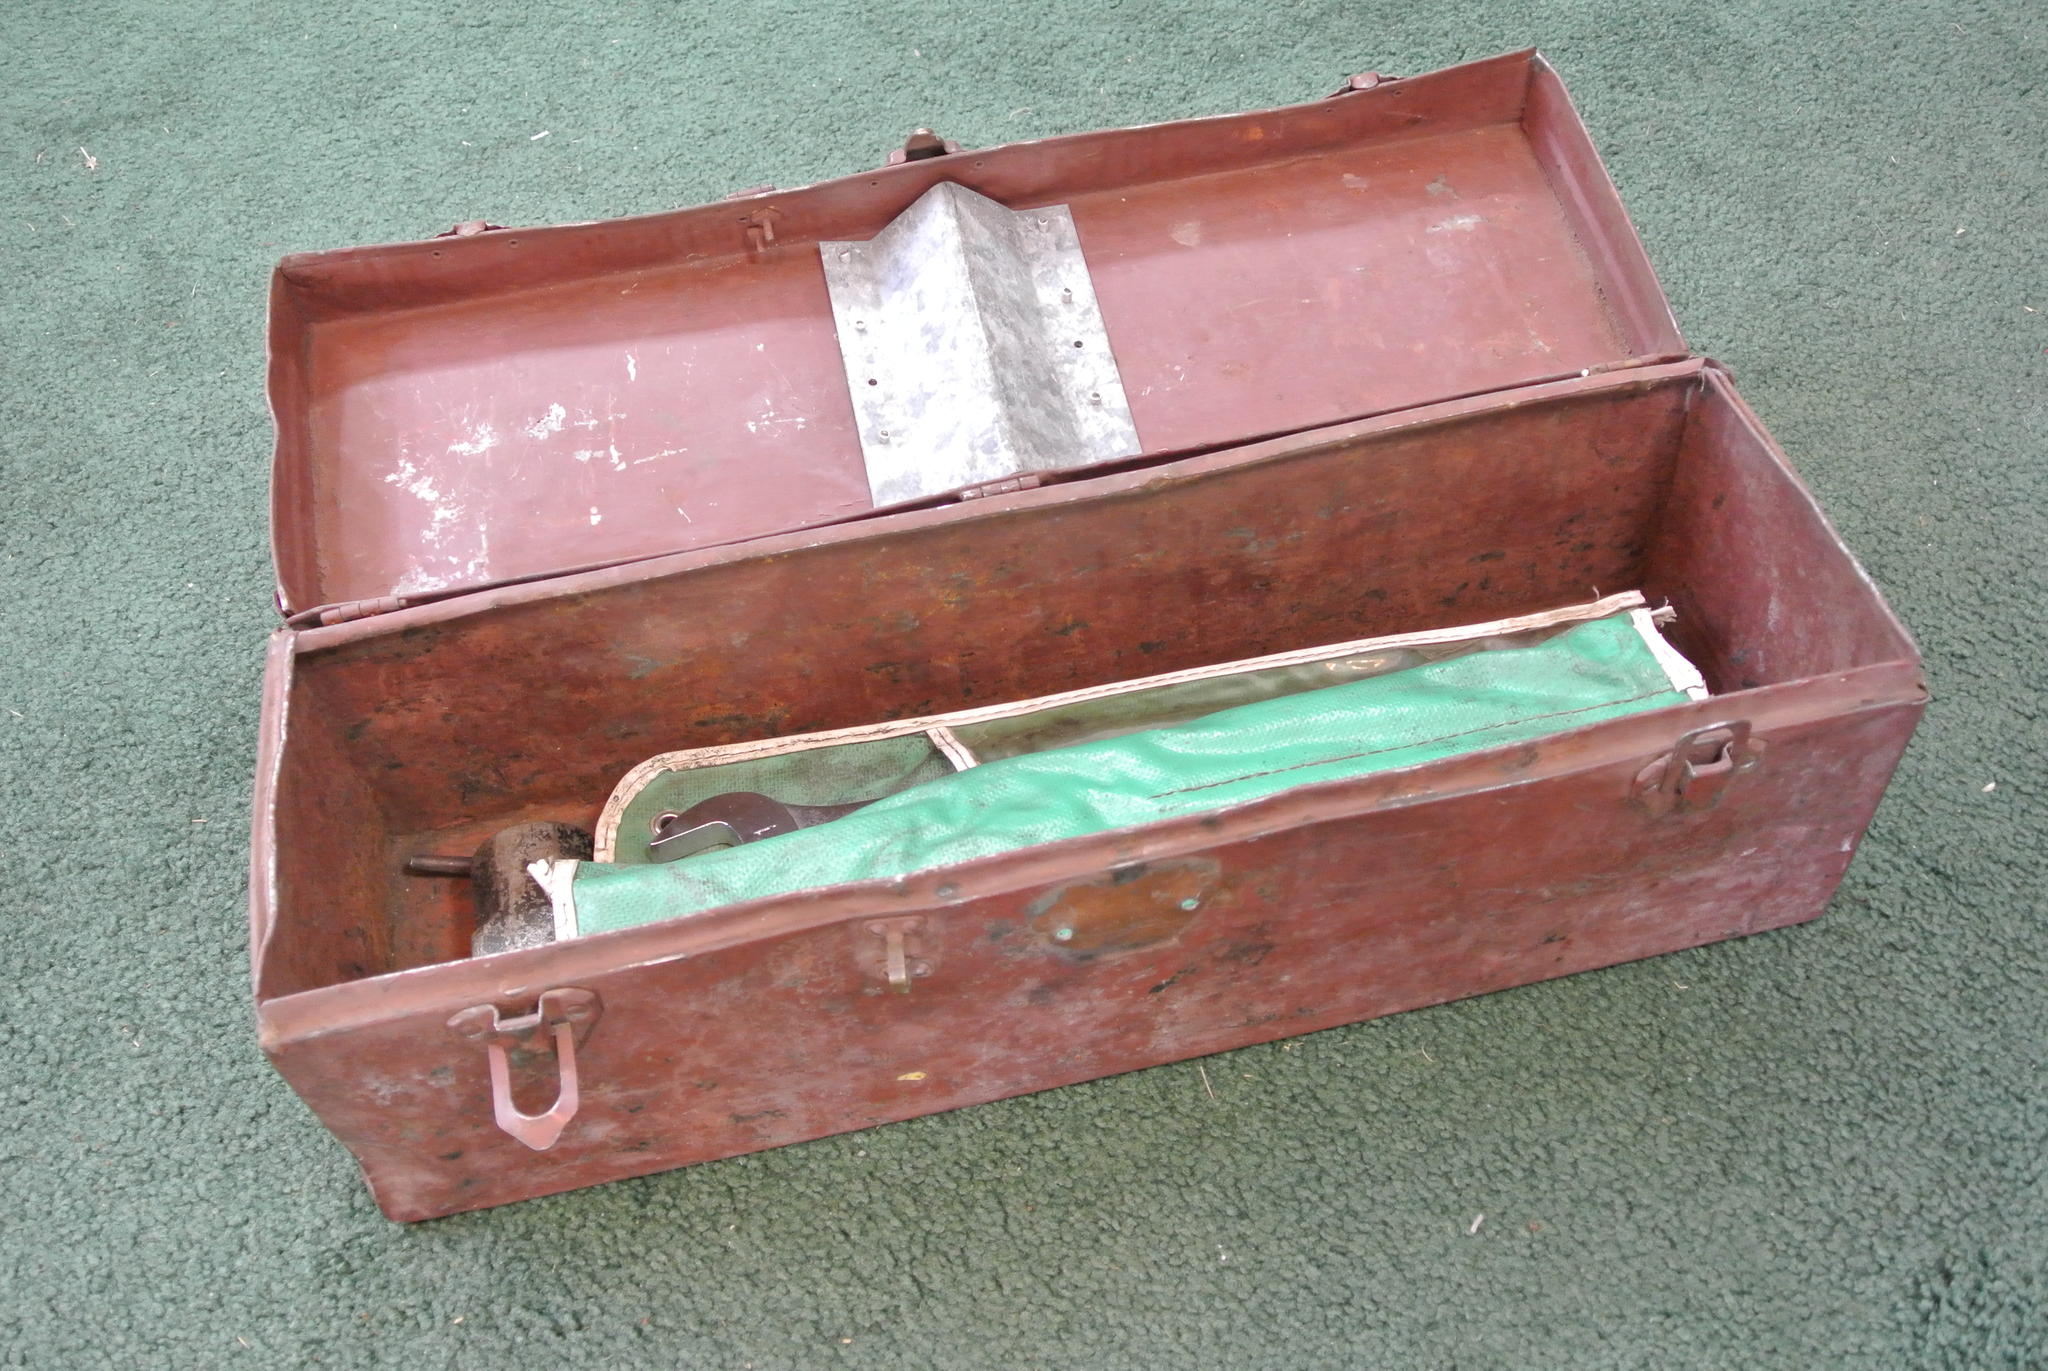Could you give a brief overview of what you see in this image? In this picture there is a box in which something is placed on the floor. 